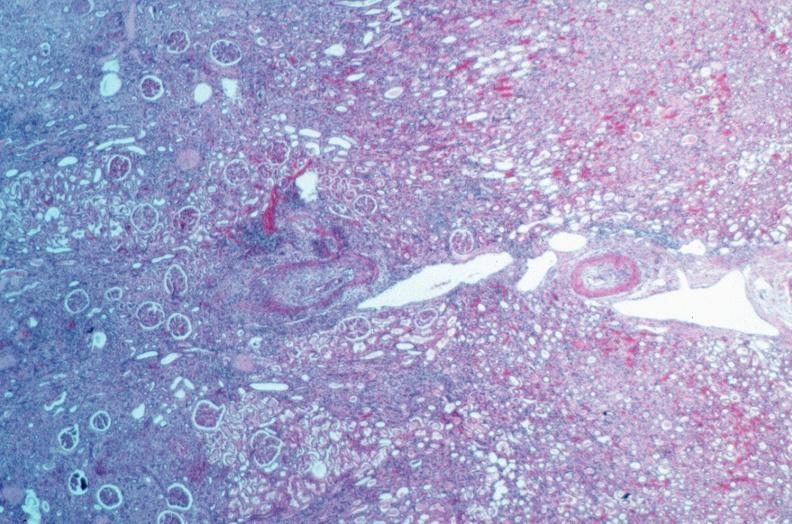does situs inversus show vasculitis, polyarteritis nodosa?
Answer the question using a single word or phrase. No 